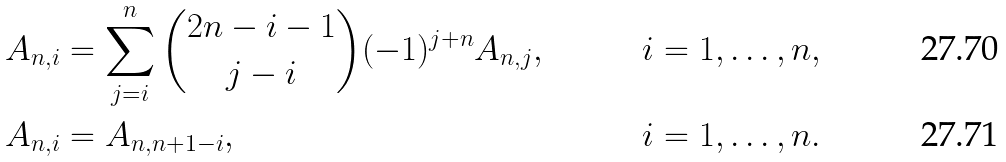Convert formula to latex. <formula><loc_0><loc_0><loc_500><loc_500>A _ { n , i } & = \sum _ { j = i } ^ { n } \binom { 2 n - i - 1 } { j - i } ( - 1 ) ^ { j + n } A _ { n , j } , & i = 1 , \dots , n , \\ A _ { n , i } & = A _ { n , n + 1 - i } , & i = 1 , \dots , n .</formula> 